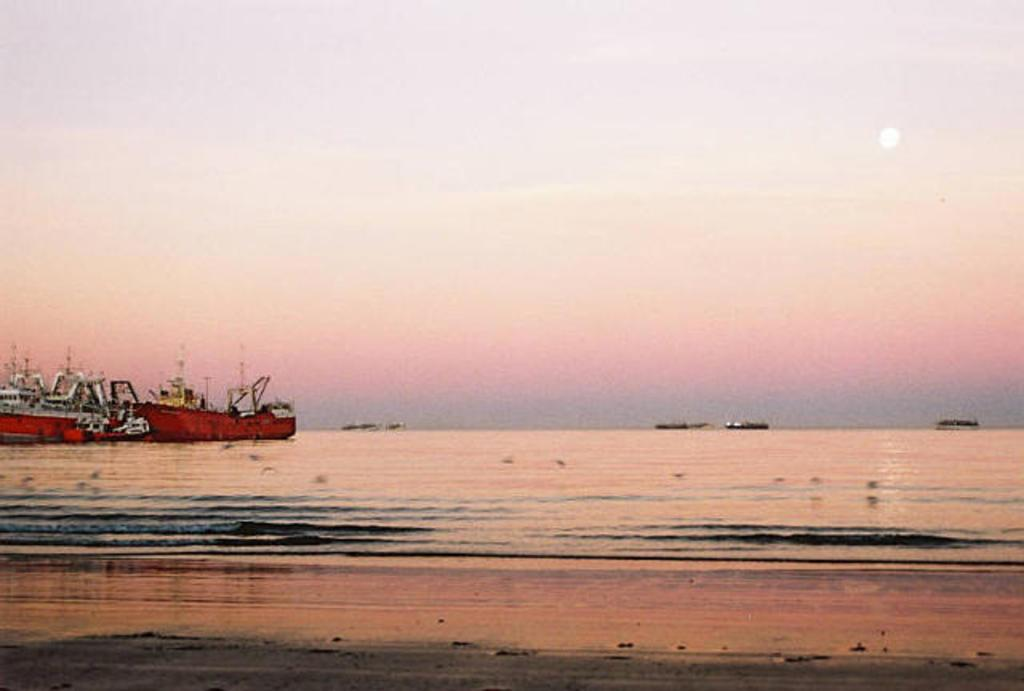What is the main subject of the image? The image depicts a sea. What can be seen on the water in the image? There are ships on the water in the image. What is visible at the top of the image? The sky is visible at the top of the image. What can be seen in the sky? The sun is present in the sky. What is visible at the bottom of the image? Water and sand are present at the bottom of the image. What type of vegetable is being cut by the scissors in the image? There are no scissors or vegetables present in the image. What kind of coach can be seen driving along the sand in the image? There is no coach present in the image; it depicts a sea with ships and sand at the bottom. 